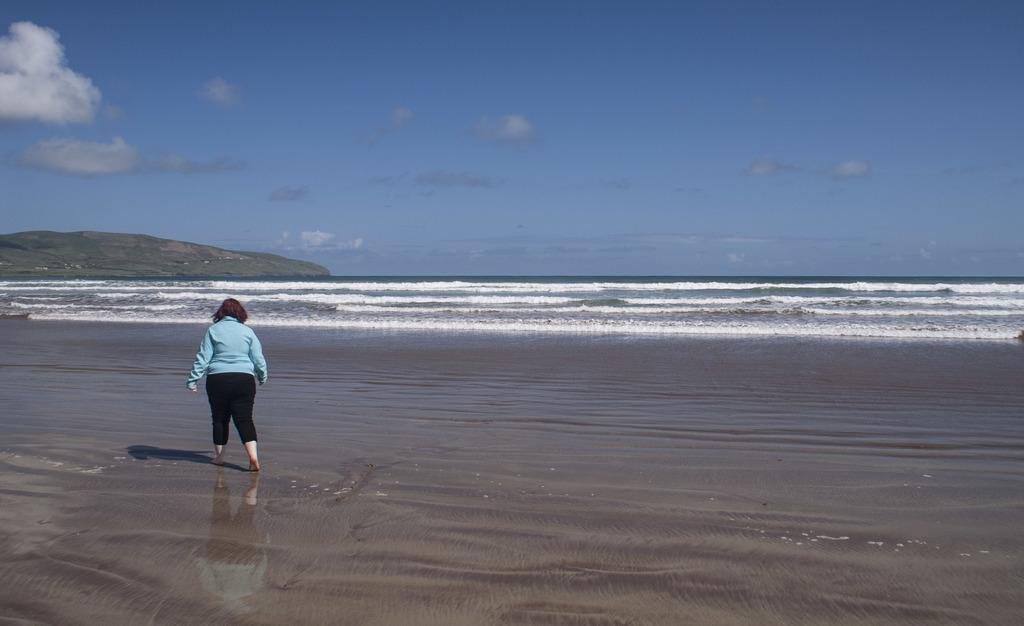What is the person in the image doing? There is a person walking in the image. What can be seen in the image besides the person? There is water visible in the image, as well as a hill and the sky. What is the condition of the sky in the image? The sky is visible in the background of the image, and clouds are present. What type of drink is the person holding in the image? There is no drink visible in the image; the person is simply walking. How many cars can be seen in the image? There are no cars present in the image. 